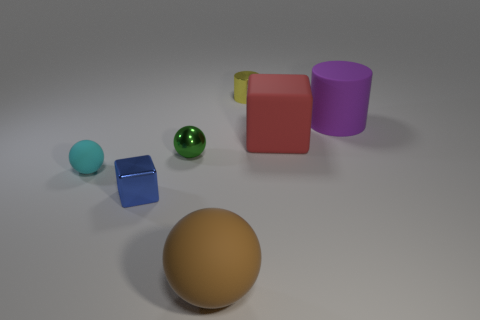Subtract all balls. How many objects are left? 4 Subtract 1 balls. How many balls are left? 2 Add 3 yellow metallic things. How many objects exist? 10 Subtract all matte balls. How many balls are left? 1 Subtract all brown cylinders. Subtract all cyan cubes. How many cylinders are left? 2 Subtract all cyan balls. How many green cylinders are left? 0 Subtract all small green metal balls. Subtract all matte balls. How many objects are left? 4 Add 1 big purple matte cylinders. How many big purple matte cylinders are left? 2 Add 5 green balls. How many green balls exist? 6 Subtract all brown spheres. How many spheres are left? 2 